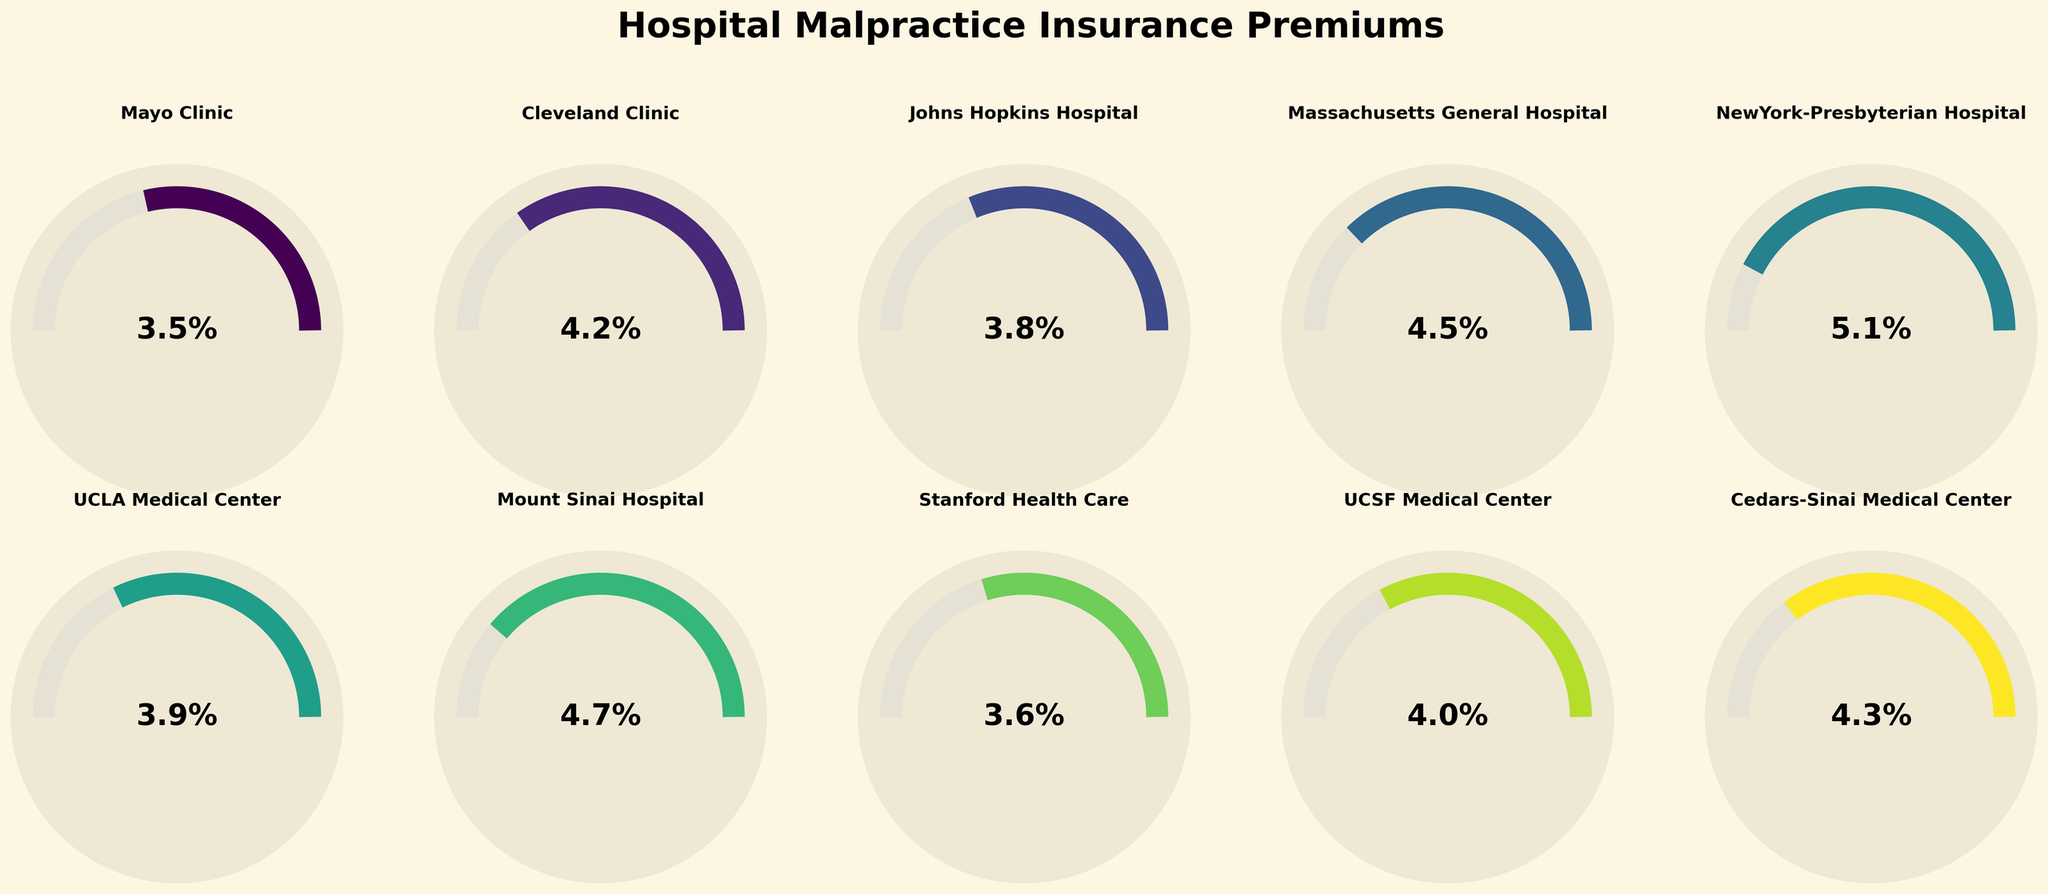What's the highest percentage allocated to malpractice insurance premiums across all hospitals? To find the highest percentage, look through the values for each hospital and identify the maximum. The highest percentage shown is 5.1% for NewYork-Presbyterian Hospital.
Answer: 5.1% What's the average percentage of hospital budget allocated to malpractice insurance premiums? Add up all the percentages and divide by the total number of hospitals. Sum: 3.5 + 4.2 + 3.8 + 4.5 + 5.1 + 3.9 + 4.7 + 3.6 + 4.0 + 4.3 = 41.6, Number of hospitals: 10, Average = 41.6/10 = 4.16%
Answer: 4.16% Which hospital has the lowest budget allocation to malpractice insurance premiums? Look through the values for each hospital to find the smallest percentage. The smallest percentage is 3.5%, allocated by Mayo Clinic.
Answer: Mayo Clinic How much higher is the malpractice insurance budget for NewYork-Presbyterian Hospital compared to Mayo Clinic? Subtract the percentage for Mayo Clinic from the percentage for NewYork-Presbyterian Hospital: 5.1% - 3.5% = 1.6%
Answer: 1.6% Among the hospitals listed, how many of them allocate more than 4% of their budget to malpractice insurance premiums? Count the number of hospitals that have a percentage higher than 4%. Hospitals: Cleveland Clinic, Massachusetts General Hospital, NewYork-Presbyterian Hospital, Mount Sinai Hospital, Cedars-Sinai Medical Center (5 hospitals)
Answer: 5 What's the range of percentage allocations to malpractice insurance premiums among the hospitals? The range is the difference between the highest and lowest percentages. Highest: 5.1%, Lowest: 3.5%, Range = 5.1% - 3.5% = 1.6%
Answer: 1.6% Do most hospitals allocate more than 4% to malpractice insurance premiums? Count the number of hospitals with percentages above 4% and compare against those below. There are 5 hospitals each below and above 4%, thus it’s evenly split.
Answer: No What percentage do Cedars-Sinai Medical Center and UCLA Medical Center allocate, on average, to malpractice insurance premiums? Add the percentages for both hospitals and divide by 2: (4.3% + 3.9%) / 2 = 4.1%
Answer: 4.1% Between Cleveland Clinic and Johns Hopkins Hospital, which hospital allocates a higher percentage of its budget to malpractice insurance? Compare the percentages: Cleveland Clinic (4.2%) vs Johns Hopkins Hospital (3.8%). Cleveland Clinic allocates more.
Answer: Cleveland Clinic 